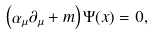<formula> <loc_0><loc_0><loc_500><loc_500>\left ( \alpha _ { \mu } \partial _ { \mu } + m \right ) \Psi ( x ) = 0 ,</formula> 